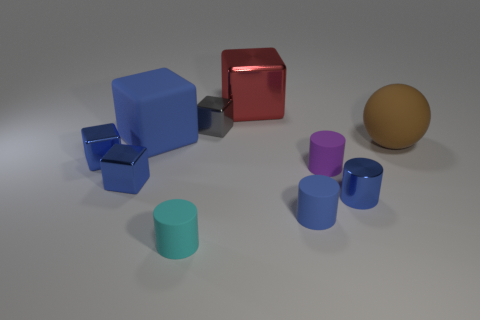What color is the object that is on the left side of the big metal cube and behind the large blue rubber block?
Your answer should be compact. Gray. How many tiny yellow matte cubes are there?
Your answer should be compact. 0. Are the large red object and the tiny gray block made of the same material?
Your response must be concise. Yes. Is the size of the matte cylinder that is left of the tiny blue matte cylinder the same as the blue metallic thing on the right side of the tiny purple matte cylinder?
Provide a short and direct response. Yes. Is the number of blue rubber cylinders less than the number of blue cubes?
Keep it short and to the point. Yes. What number of rubber objects are either big red cubes or large blue things?
Your response must be concise. 1. There is a small cylinder that is to the right of the purple rubber thing; is there a small cube that is to the right of it?
Give a very brief answer. No. Are the big cube on the right side of the cyan cylinder and the large brown sphere made of the same material?
Your response must be concise. No. How many other objects are the same color as the matte block?
Offer a very short reply. 4. Is the color of the tiny metal cylinder the same as the big matte cube?
Provide a succinct answer. Yes. 